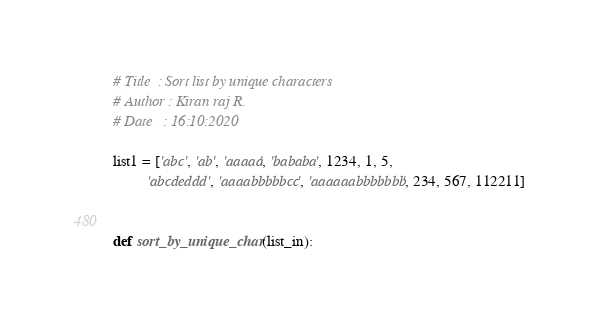<code> <loc_0><loc_0><loc_500><loc_500><_Python_># Title  : Sort list by unique characters
# Author : Kiran raj R.
# Date   : 16:10:2020

list1 = ['abc', 'ab', 'aaaaa', 'bababa', 1234, 1, 5,
         'abcdeddd', 'aaaabbbbbcc', 'aaaaaabbbbbbb', 234, 567, 112211]


def sort_by_unique_char(list_in):</code> 